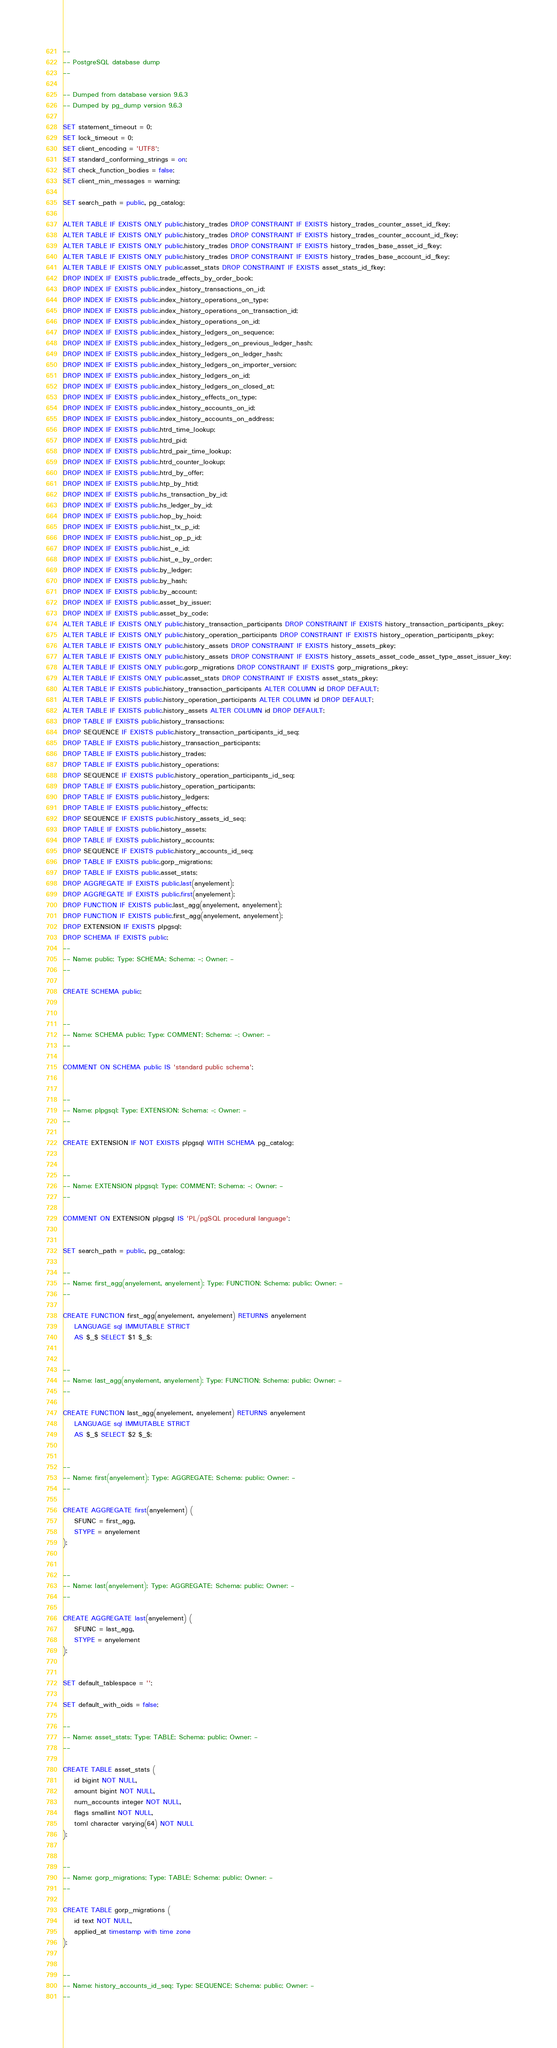<code> <loc_0><loc_0><loc_500><loc_500><_SQL_>--
-- PostgreSQL database dump
--

-- Dumped from database version 9.6.3
-- Dumped by pg_dump version 9.6.3

SET statement_timeout = 0;
SET lock_timeout = 0;
SET client_encoding = 'UTF8';
SET standard_conforming_strings = on;
SET check_function_bodies = false;
SET client_min_messages = warning;

SET search_path = public, pg_catalog;

ALTER TABLE IF EXISTS ONLY public.history_trades DROP CONSTRAINT IF EXISTS history_trades_counter_asset_id_fkey;
ALTER TABLE IF EXISTS ONLY public.history_trades DROP CONSTRAINT IF EXISTS history_trades_counter_account_id_fkey;
ALTER TABLE IF EXISTS ONLY public.history_trades DROP CONSTRAINT IF EXISTS history_trades_base_asset_id_fkey;
ALTER TABLE IF EXISTS ONLY public.history_trades DROP CONSTRAINT IF EXISTS history_trades_base_account_id_fkey;
ALTER TABLE IF EXISTS ONLY public.asset_stats DROP CONSTRAINT IF EXISTS asset_stats_id_fkey;
DROP INDEX IF EXISTS public.trade_effects_by_order_book;
DROP INDEX IF EXISTS public.index_history_transactions_on_id;
DROP INDEX IF EXISTS public.index_history_operations_on_type;
DROP INDEX IF EXISTS public.index_history_operations_on_transaction_id;
DROP INDEX IF EXISTS public.index_history_operations_on_id;
DROP INDEX IF EXISTS public.index_history_ledgers_on_sequence;
DROP INDEX IF EXISTS public.index_history_ledgers_on_previous_ledger_hash;
DROP INDEX IF EXISTS public.index_history_ledgers_on_ledger_hash;
DROP INDEX IF EXISTS public.index_history_ledgers_on_importer_version;
DROP INDEX IF EXISTS public.index_history_ledgers_on_id;
DROP INDEX IF EXISTS public.index_history_ledgers_on_closed_at;
DROP INDEX IF EXISTS public.index_history_effects_on_type;
DROP INDEX IF EXISTS public.index_history_accounts_on_id;
DROP INDEX IF EXISTS public.index_history_accounts_on_address;
DROP INDEX IF EXISTS public.htrd_time_lookup;
DROP INDEX IF EXISTS public.htrd_pid;
DROP INDEX IF EXISTS public.htrd_pair_time_lookup;
DROP INDEX IF EXISTS public.htrd_counter_lookup;
DROP INDEX IF EXISTS public.htrd_by_offer;
DROP INDEX IF EXISTS public.htp_by_htid;
DROP INDEX IF EXISTS public.hs_transaction_by_id;
DROP INDEX IF EXISTS public.hs_ledger_by_id;
DROP INDEX IF EXISTS public.hop_by_hoid;
DROP INDEX IF EXISTS public.hist_tx_p_id;
DROP INDEX IF EXISTS public.hist_op_p_id;
DROP INDEX IF EXISTS public.hist_e_id;
DROP INDEX IF EXISTS public.hist_e_by_order;
DROP INDEX IF EXISTS public.by_ledger;
DROP INDEX IF EXISTS public.by_hash;
DROP INDEX IF EXISTS public.by_account;
DROP INDEX IF EXISTS public.asset_by_issuer;
DROP INDEX IF EXISTS public.asset_by_code;
ALTER TABLE IF EXISTS ONLY public.history_transaction_participants DROP CONSTRAINT IF EXISTS history_transaction_participants_pkey;
ALTER TABLE IF EXISTS ONLY public.history_operation_participants DROP CONSTRAINT IF EXISTS history_operation_participants_pkey;
ALTER TABLE IF EXISTS ONLY public.history_assets DROP CONSTRAINT IF EXISTS history_assets_pkey;
ALTER TABLE IF EXISTS ONLY public.history_assets DROP CONSTRAINT IF EXISTS history_assets_asset_code_asset_type_asset_issuer_key;
ALTER TABLE IF EXISTS ONLY public.gorp_migrations DROP CONSTRAINT IF EXISTS gorp_migrations_pkey;
ALTER TABLE IF EXISTS ONLY public.asset_stats DROP CONSTRAINT IF EXISTS asset_stats_pkey;
ALTER TABLE IF EXISTS public.history_transaction_participants ALTER COLUMN id DROP DEFAULT;
ALTER TABLE IF EXISTS public.history_operation_participants ALTER COLUMN id DROP DEFAULT;
ALTER TABLE IF EXISTS public.history_assets ALTER COLUMN id DROP DEFAULT;
DROP TABLE IF EXISTS public.history_transactions;
DROP SEQUENCE IF EXISTS public.history_transaction_participants_id_seq;
DROP TABLE IF EXISTS public.history_transaction_participants;
DROP TABLE IF EXISTS public.history_trades;
DROP TABLE IF EXISTS public.history_operations;
DROP SEQUENCE IF EXISTS public.history_operation_participants_id_seq;
DROP TABLE IF EXISTS public.history_operation_participants;
DROP TABLE IF EXISTS public.history_ledgers;
DROP TABLE IF EXISTS public.history_effects;
DROP SEQUENCE IF EXISTS public.history_assets_id_seq;
DROP TABLE IF EXISTS public.history_assets;
DROP TABLE IF EXISTS public.history_accounts;
DROP SEQUENCE IF EXISTS public.history_accounts_id_seq;
DROP TABLE IF EXISTS public.gorp_migrations;
DROP TABLE IF EXISTS public.asset_stats;
DROP AGGREGATE IF EXISTS public.last(anyelement);
DROP AGGREGATE IF EXISTS public.first(anyelement);
DROP FUNCTION IF EXISTS public.last_agg(anyelement, anyelement);
DROP FUNCTION IF EXISTS public.first_agg(anyelement, anyelement);
DROP EXTENSION IF EXISTS plpgsql;
DROP SCHEMA IF EXISTS public;
--
-- Name: public; Type: SCHEMA; Schema: -; Owner: -
--

CREATE SCHEMA public;


--
-- Name: SCHEMA public; Type: COMMENT; Schema: -; Owner: -
--

COMMENT ON SCHEMA public IS 'standard public schema';


--
-- Name: plpgsql; Type: EXTENSION; Schema: -; Owner: -
--

CREATE EXTENSION IF NOT EXISTS plpgsql WITH SCHEMA pg_catalog;


--
-- Name: EXTENSION plpgsql; Type: COMMENT; Schema: -; Owner: -
--

COMMENT ON EXTENSION plpgsql IS 'PL/pgSQL procedural language';


SET search_path = public, pg_catalog;

--
-- Name: first_agg(anyelement, anyelement); Type: FUNCTION; Schema: public; Owner: -
--

CREATE FUNCTION first_agg(anyelement, anyelement) RETURNS anyelement
    LANGUAGE sql IMMUTABLE STRICT
    AS $_$ SELECT $1 $_$;


--
-- Name: last_agg(anyelement, anyelement); Type: FUNCTION; Schema: public; Owner: -
--

CREATE FUNCTION last_agg(anyelement, anyelement) RETURNS anyelement
    LANGUAGE sql IMMUTABLE STRICT
    AS $_$ SELECT $2 $_$;


--
-- Name: first(anyelement); Type: AGGREGATE; Schema: public; Owner: -
--

CREATE AGGREGATE first(anyelement) (
    SFUNC = first_agg,
    STYPE = anyelement
);


--
-- Name: last(anyelement); Type: AGGREGATE; Schema: public; Owner: -
--

CREATE AGGREGATE last(anyelement) (
    SFUNC = last_agg,
    STYPE = anyelement
);


SET default_tablespace = '';

SET default_with_oids = false;

--
-- Name: asset_stats; Type: TABLE; Schema: public; Owner: -
--

CREATE TABLE asset_stats (
    id bigint NOT NULL,
    amount bigint NOT NULL,
    num_accounts integer NOT NULL,
    flags smallint NOT NULL,
    toml character varying(64) NOT NULL
);


--
-- Name: gorp_migrations; Type: TABLE; Schema: public; Owner: -
--

CREATE TABLE gorp_migrations (
    id text NOT NULL,
    applied_at timestamp with time zone
);


--
-- Name: history_accounts_id_seq; Type: SEQUENCE; Schema: public; Owner: -
--
</code> 